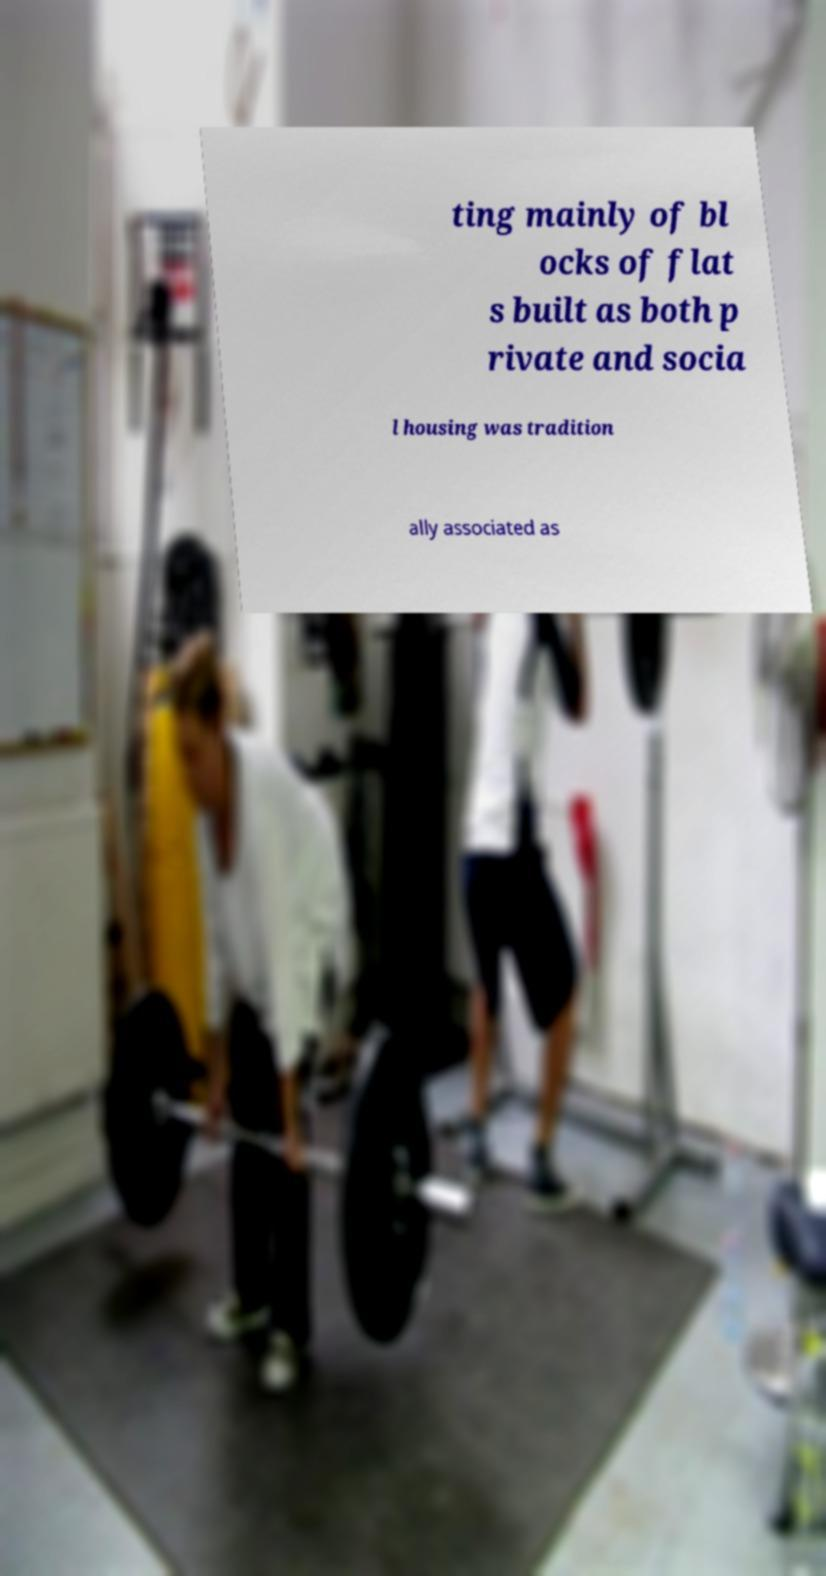Can you read and provide the text displayed in the image?This photo seems to have some interesting text. Can you extract and type it out for me? ting mainly of bl ocks of flat s built as both p rivate and socia l housing was tradition ally associated as 